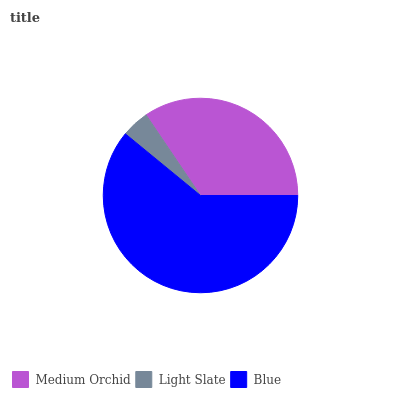Is Light Slate the minimum?
Answer yes or no. Yes. Is Blue the maximum?
Answer yes or no. Yes. Is Blue the minimum?
Answer yes or no. No. Is Light Slate the maximum?
Answer yes or no. No. Is Blue greater than Light Slate?
Answer yes or no. Yes. Is Light Slate less than Blue?
Answer yes or no. Yes. Is Light Slate greater than Blue?
Answer yes or no. No. Is Blue less than Light Slate?
Answer yes or no. No. Is Medium Orchid the high median?
Answer yes or no. Yes. Is Medium Orchid the low median?
Answer yes or no. Yes. Is Blue the high median?
Answer yes or no. No. Is Blue the low median?
Answer yes or no. No. 